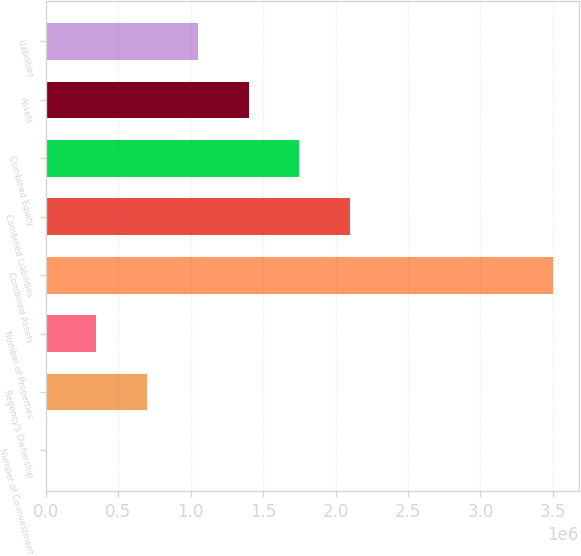Convert chart to OTSL. <chart><loc_0><loc_0><loc_500><loc_500><bar_chart><fcel>Number of Co-investment<fcel>Regency's Ownership<fcel>Number of Properties<fcel>Combined Assets<fcel>Combined Liabilities<fcel>Combined Equity<fcel>Assets<fcel>Liabilities<nl><fcel>16<fcel>700368<fcel>350192<fcel>3.50178e+06<fcel>2.10107e+06<fcel>1.7509e+06<fcel>1.40072e+06<fcel>1.05054e+06<nl></chart> 